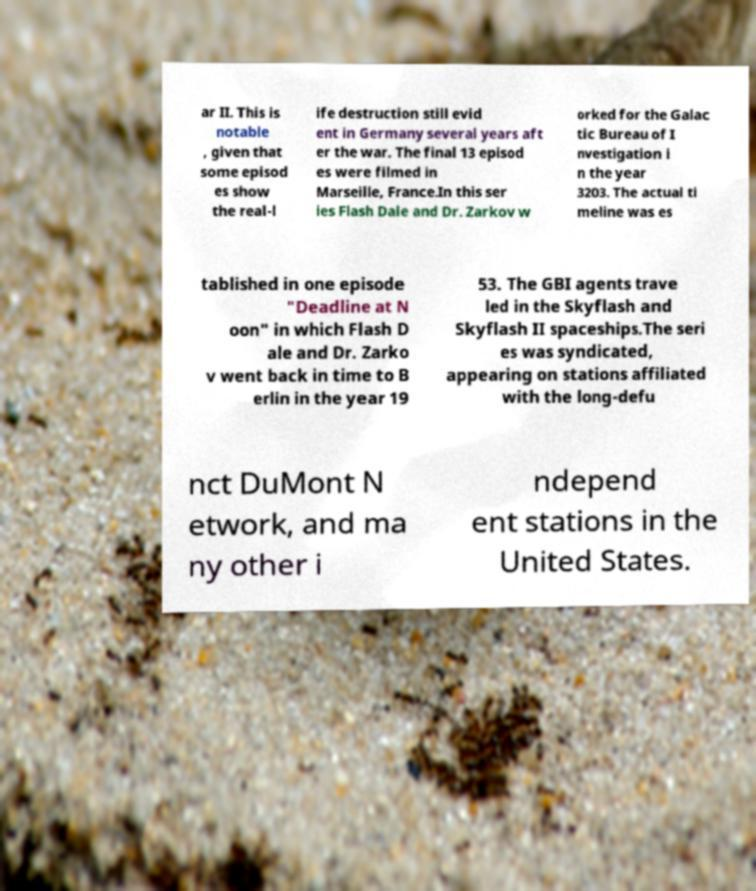Please read and relay the text visible in this image. What does it say? ar II. This is notable , given that some episod es show the real-l ife destruction still evid ent in Germany several years aft er the war. The final 13 episod es were filmed in Marseille, France.In this ser ies Flash Dale and Dr. Zarkov w orked for the Galac tic Bureau of I nvestigation i n the year 3203. The actual ti meline was es tablished in one episode "Deadline at N oon" in which Flash D ale and Dr. Zarko v went back in time to B erlin in the year 19 53. The GBI agents trave led in the Skyflash and Skyflash II spaceships.The seri es was syndicated, appearing on stations affiliated with the long-defu nct DuMont N etwork, and ma ny other i ndepend ent stations in the United States. 